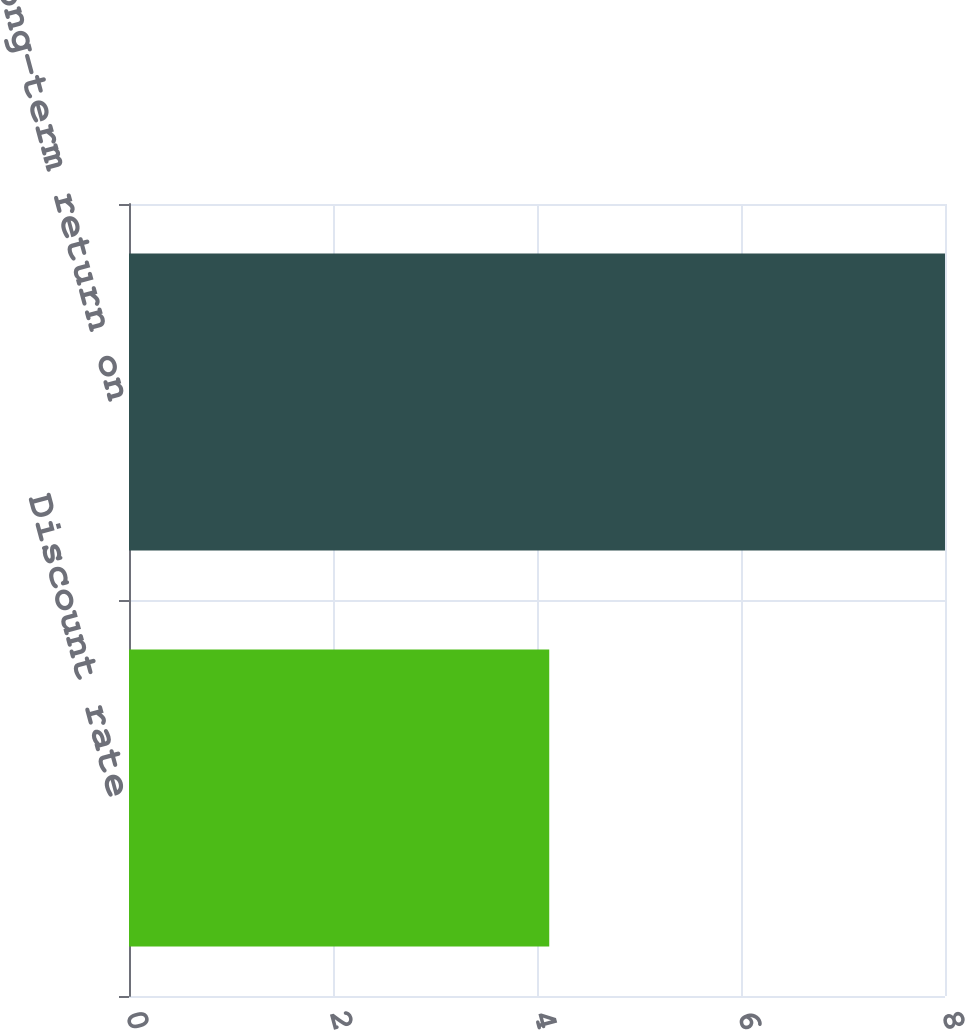Convert chart to OTSL. <chart><loc_0><loc_0><loc_500><loc_500><bar_chart><fcel>Discount rate<fcel>Expected long-term return on<nl><fcel>4.12<fcel>8<nl></chart> 